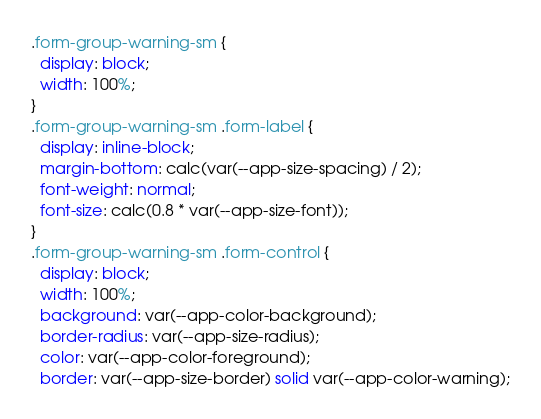Convert code to text. <code><loc_0><loc_0><loc_500><loc_500><_CSS_>.form-group-warning-sm {
  display: block;
  width: 100%;
}
.form-group-warning-sm .form-label {
  display: inline-block;
  margin-bottom: calc(var(--app-size-spacing) / 2);
  font-weight: normal;
  font-size: calc(0.8 * var(--app-size-font));
}
.form-group-warning-sm .form-control {
  display: block;
  width: 100%;
  background: var(--app-color-background);
  border-radius: var(--app-size-radius);
  color: var(--app-color-foreground);
  border: var(--app-size-border) solid var(--app-color-warning);</code> 